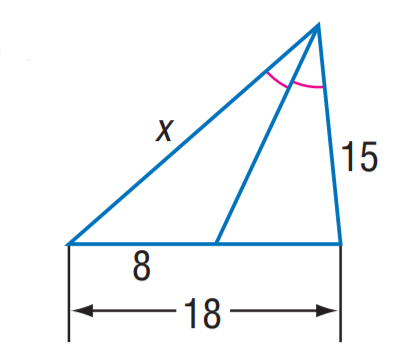Question: Find x.
Choices:
A. 8
B. 9
C. 12
D. 15
Answer with the letter. Answer: C 